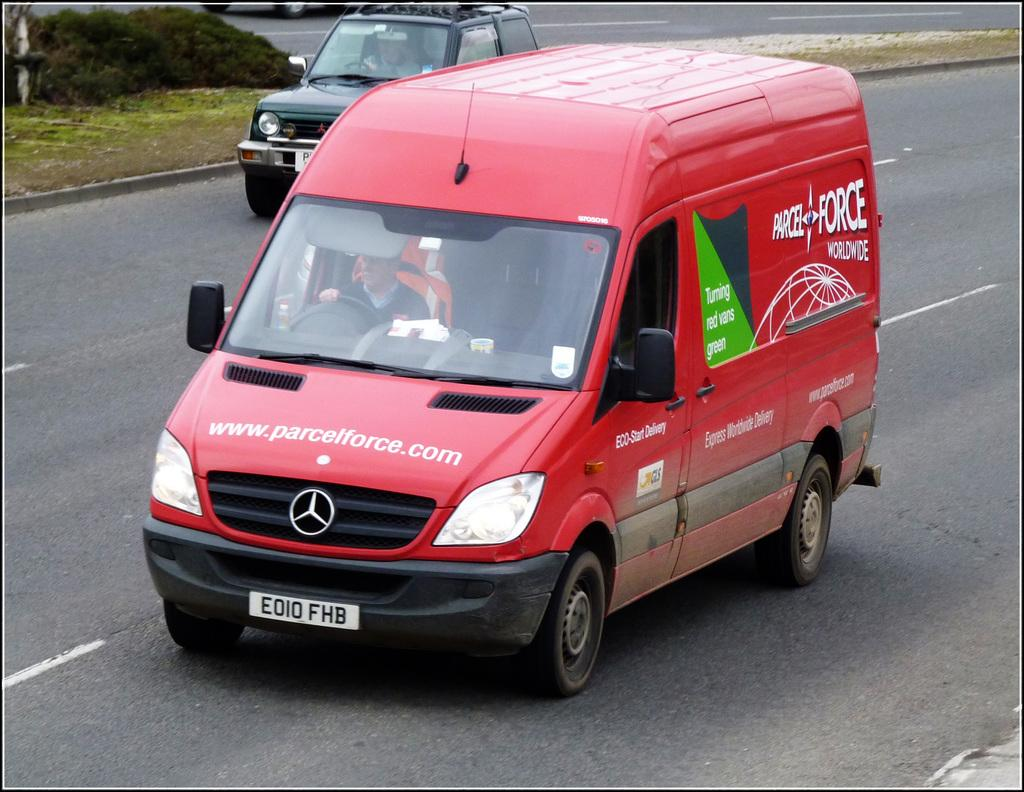Provide a one-sentence caption for the provided image. A re delivery fan on the road from Parcel Force. 